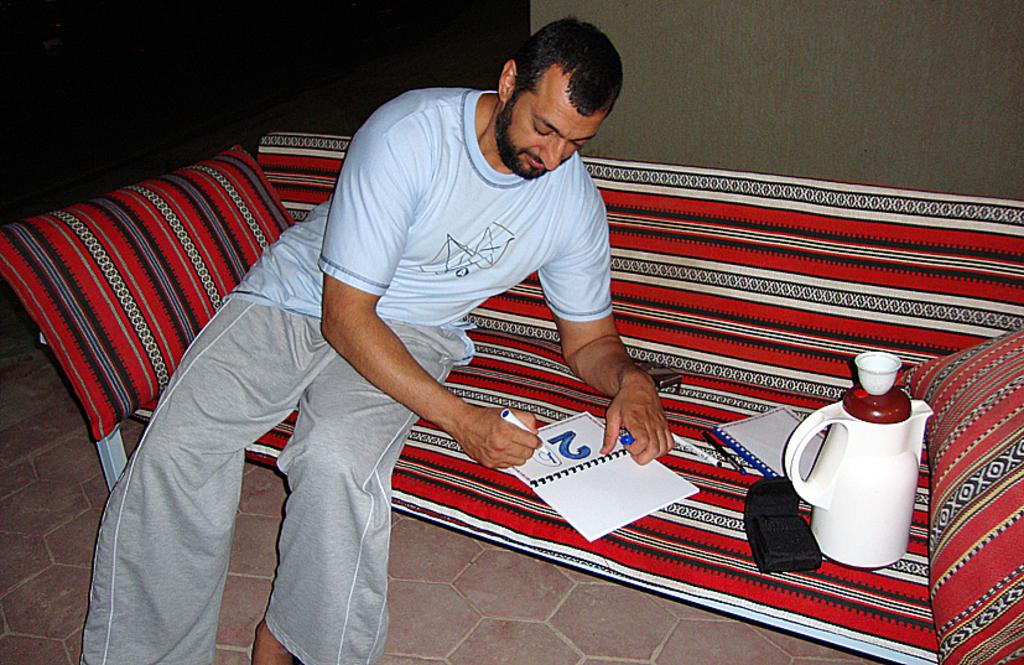<image>
Present a compact description of the photo's key features. Man writing in a notepad that has the number 2 on it. 